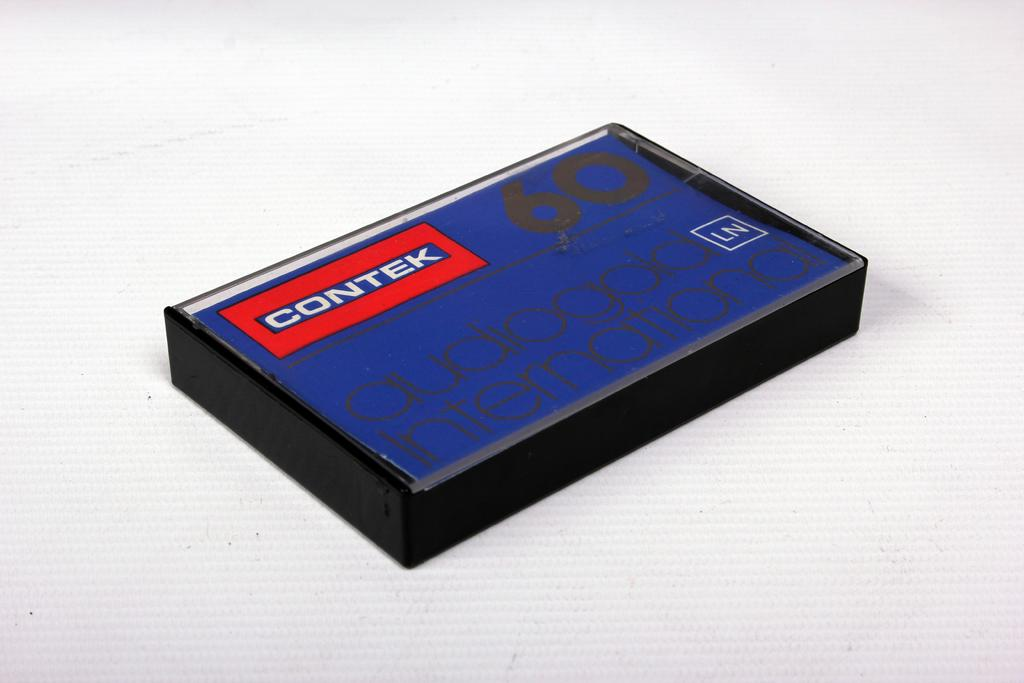<image>
Relay a brief, clear account of the picture shown. a blue cassett tape with black writing by contek 